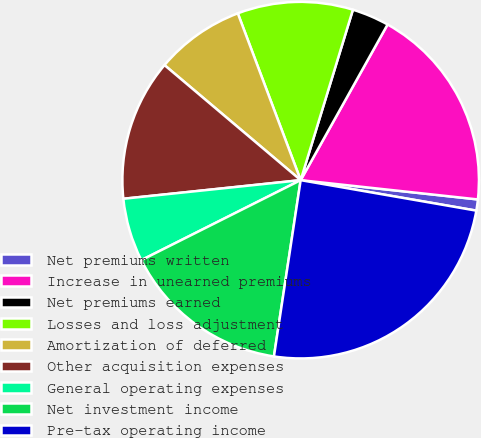Convert chart. <chart><loc_0><loc_0><loc_500><loc_500><pie_chart><fcel>Net premiums written<fcel>Increase in unearned premiums<fcel>Net premiums earned<fcel>Losses and loss adjustment<fcel>Amortization of deferred<fcel>Other acquisition expenses<fcel>General operating expenses<fcel>Net investment income<fcel>Pre-tax operating income<nl><fcel>1.01%<fcel>18.62%<fcel>3.37%<fcel>10.47%<fcel>8.1%<fcel>12.83%<fcel>5.74%<fcel>15.2%<fcel>24.66%<nl></chart> 